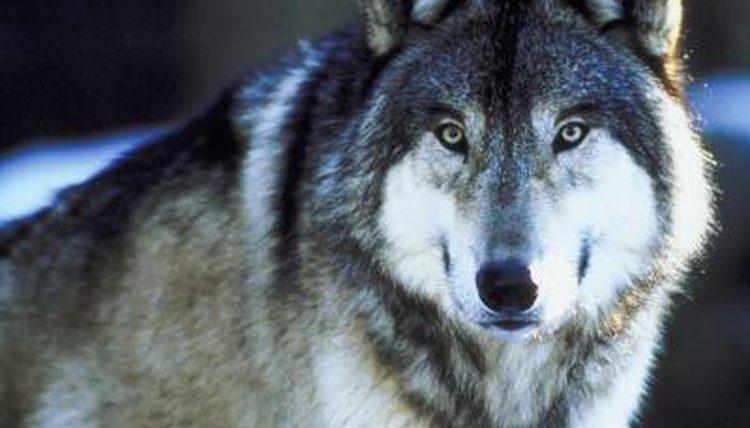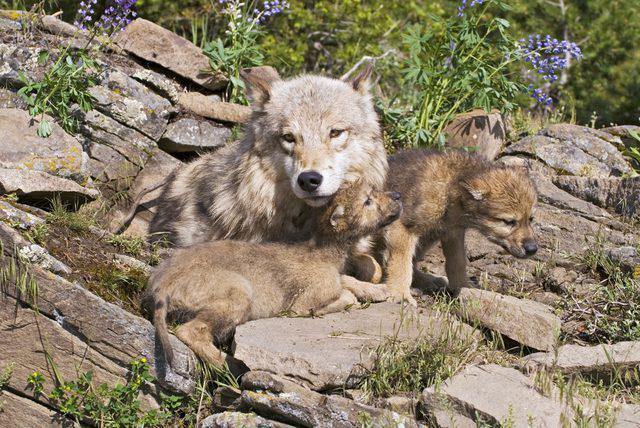The first image is the image on the left, the second image is the image on the right. For the images shown, is this caption "The right image contains multiple animals." true? Answer yes or no. Yes. The first image is the image on the left, the second image is the image on the right. Considering the images on both sides, is "There is more than one wolf in the image on the right." valid? Answer yes or no. Yes. 